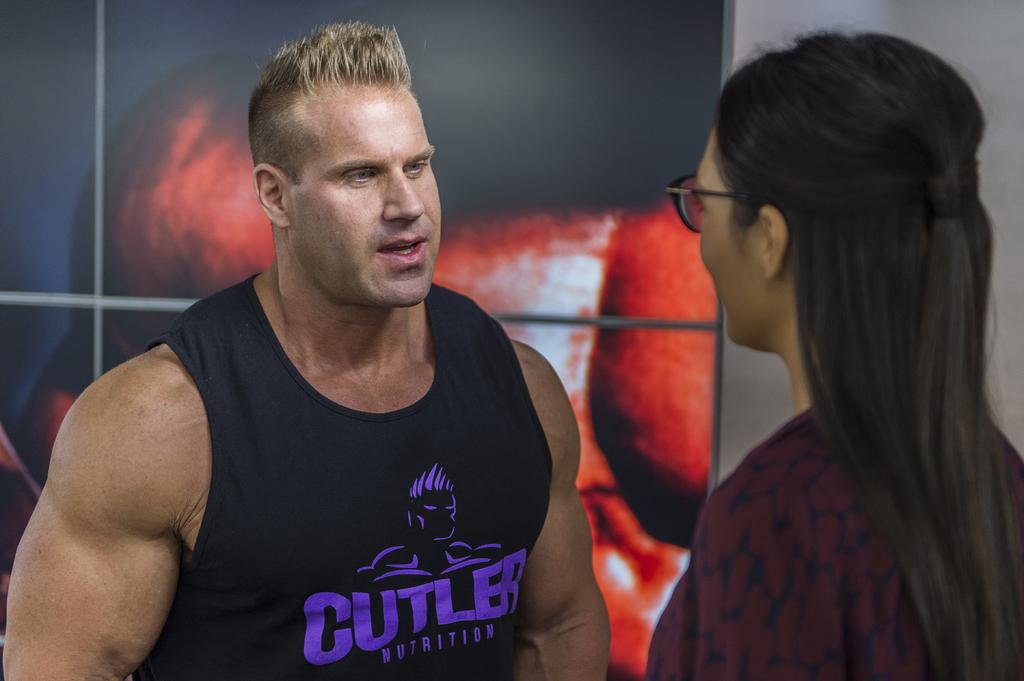<image>
Write a terse but informative summary of the picture. the man is wearing a top saying Cutler on the front 